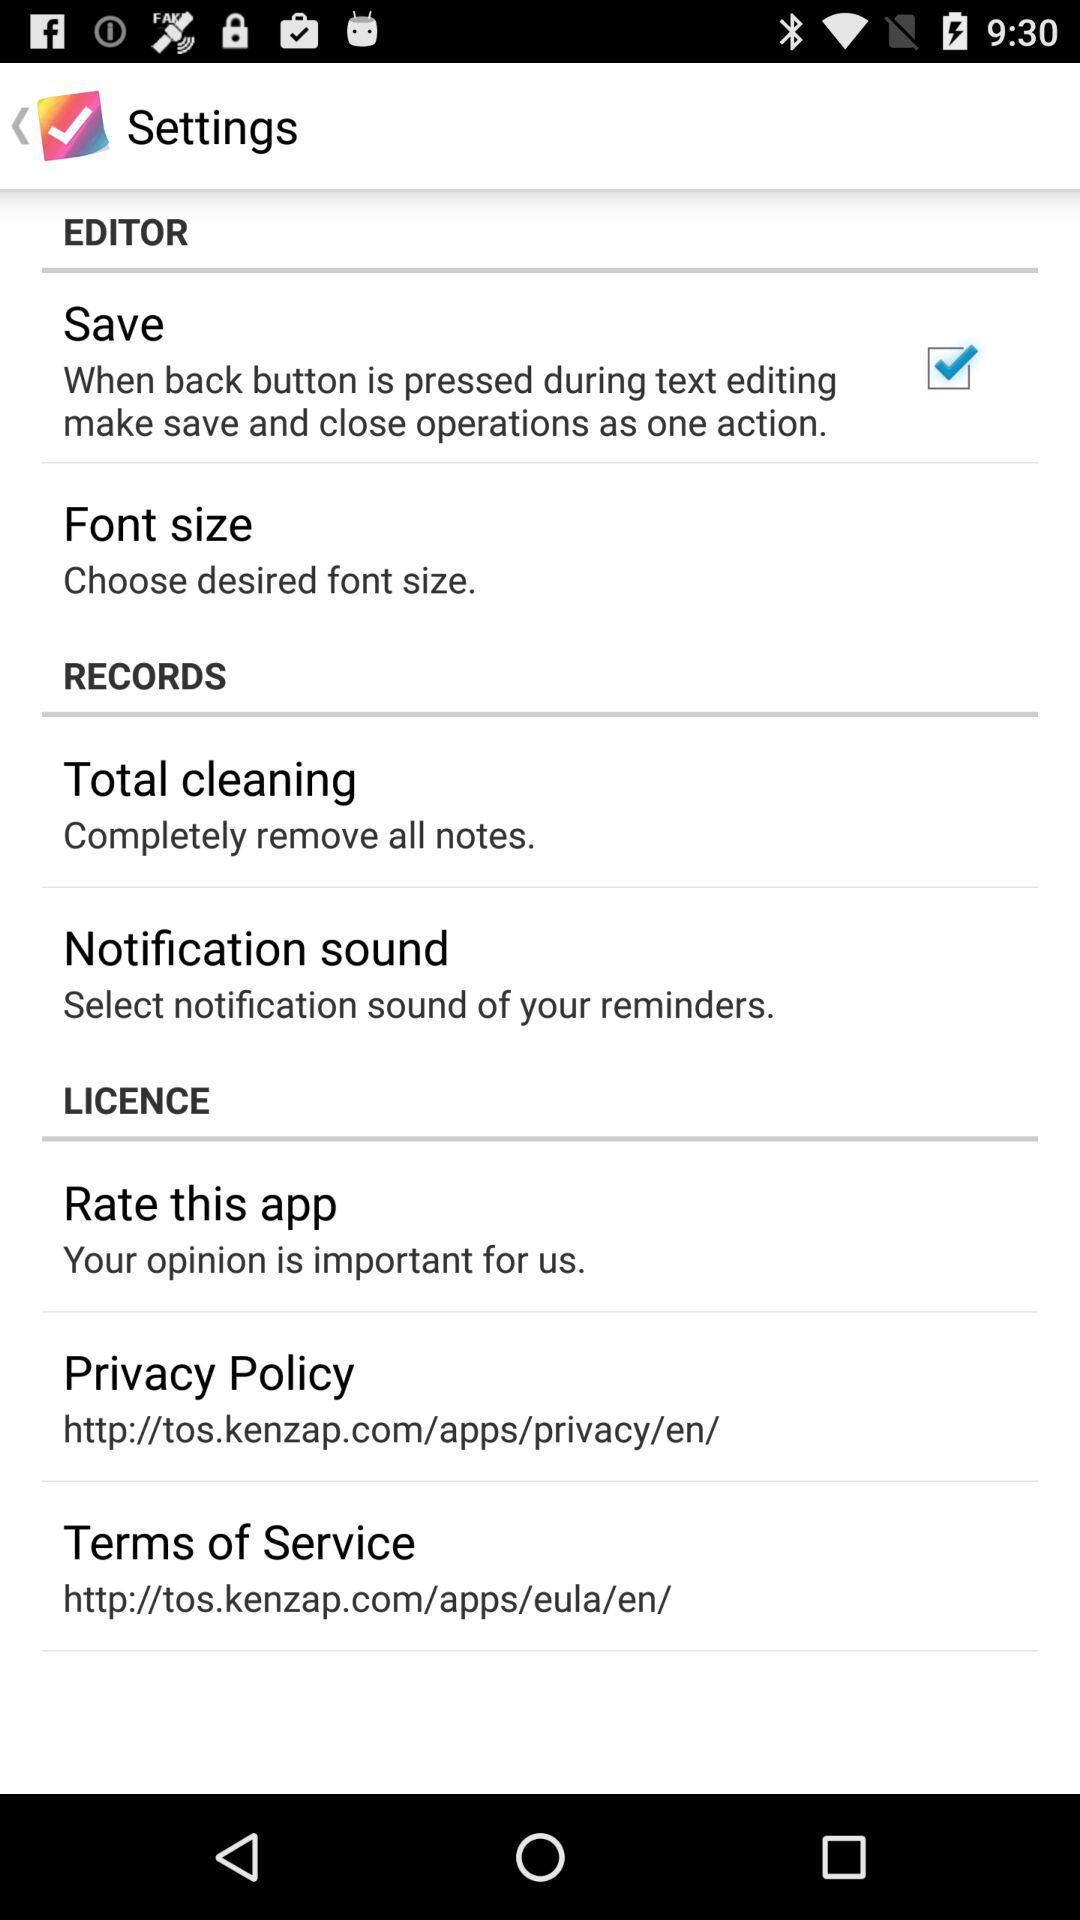What is the URL for the privacy policy? The URL is http://tos.kenzap.com/apps/privacy/en/. 